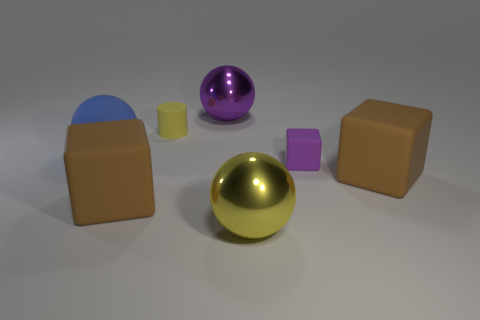What is the purpose of the different objects arranged in the image? The image appears to be a setup showing various geometric shapes and materials, possibly for the purpose of visual demonstration or as part of a 3D rendering test. Each object can illustrate how light and shadows interact with different surfaces, or it could be a basic composition exercise in a digital art context. 